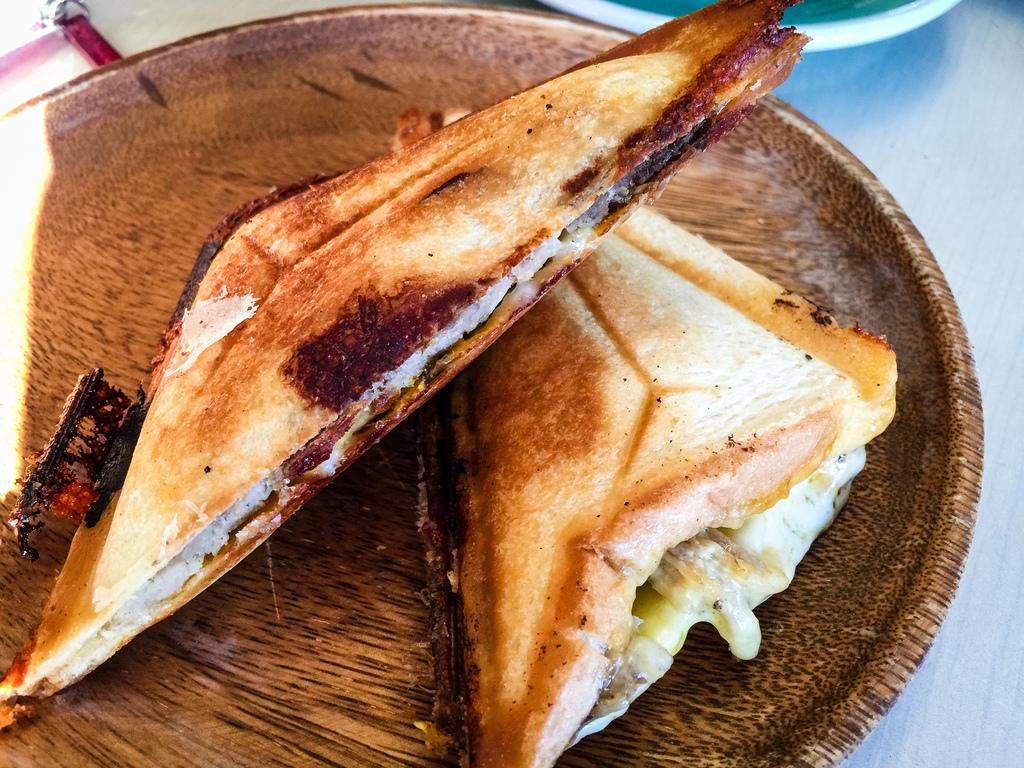What piece of furniture is present in the image? There is a table in the image. What is placed on the table? There are plates and sandwiches on the table. What type of thread is used to sew the sandwiches together in the image? There is no thread or sewing involved in the sandwiches in the image; they are simply placed on the plates. 